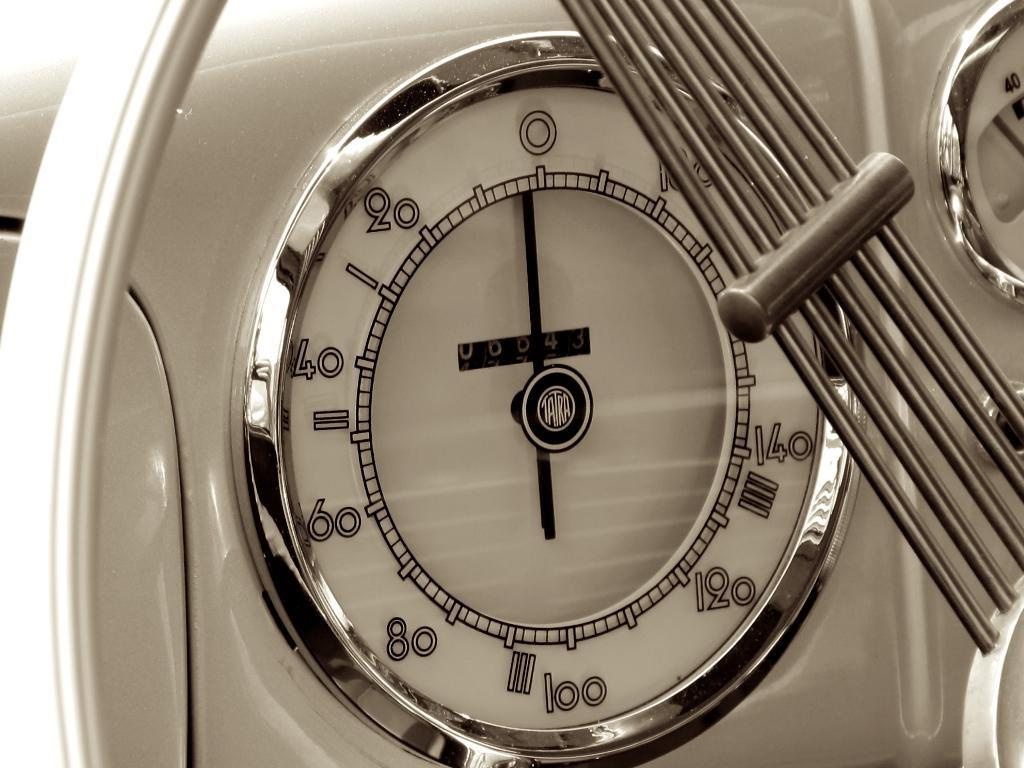<image>
Create a compact narrative representing the image presented. A kitchen thermometer shows numbers including 20, 40 and 60. 